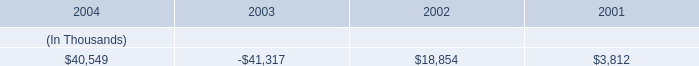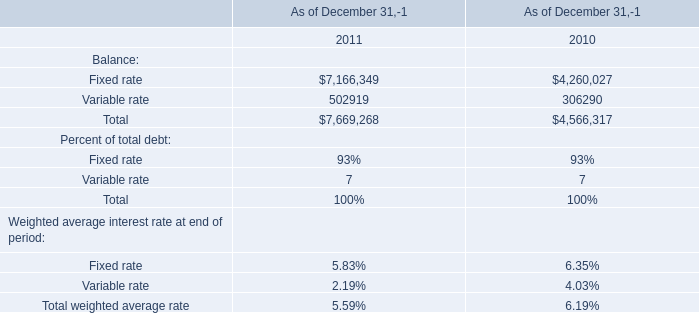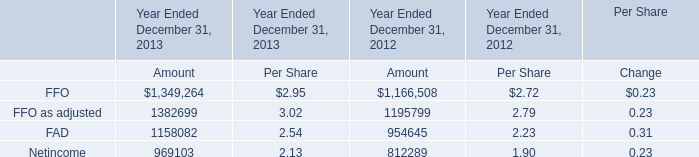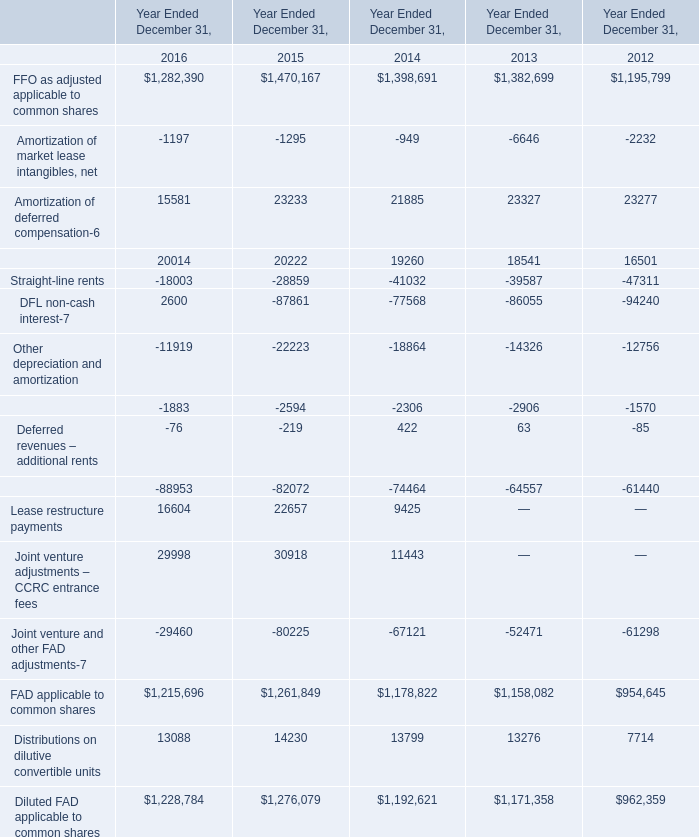What's the average of Lease restructure payments of Year Ended December 31, 2016, and FAD of Year Ended December 31, 2012 Amount ? 
Computations: ((16604.0 + 954645.0) / 2)
Answer: 485624.5. 